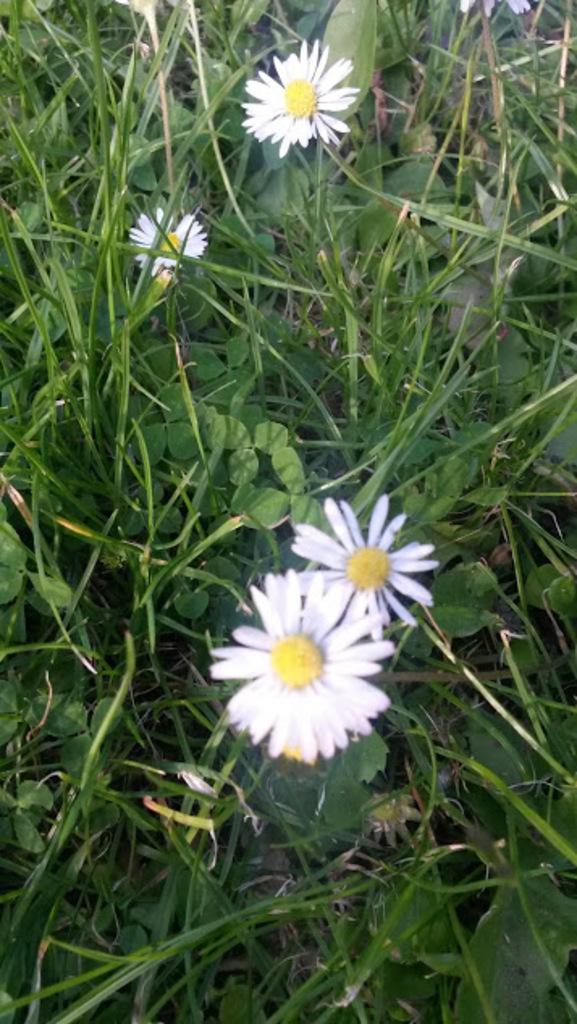What type of vegetation can be seen in the image? There are flowers, plants, and grass visible in the image. Can you describe the natural environment depicted in the image? The image features a variety of vegetation, including flowers, plants, and grass. What subject is being taught in the image? There is no indication of teaching or any educational activity in the image. Is there a jail visible in the image? There is no jail present in the image. 